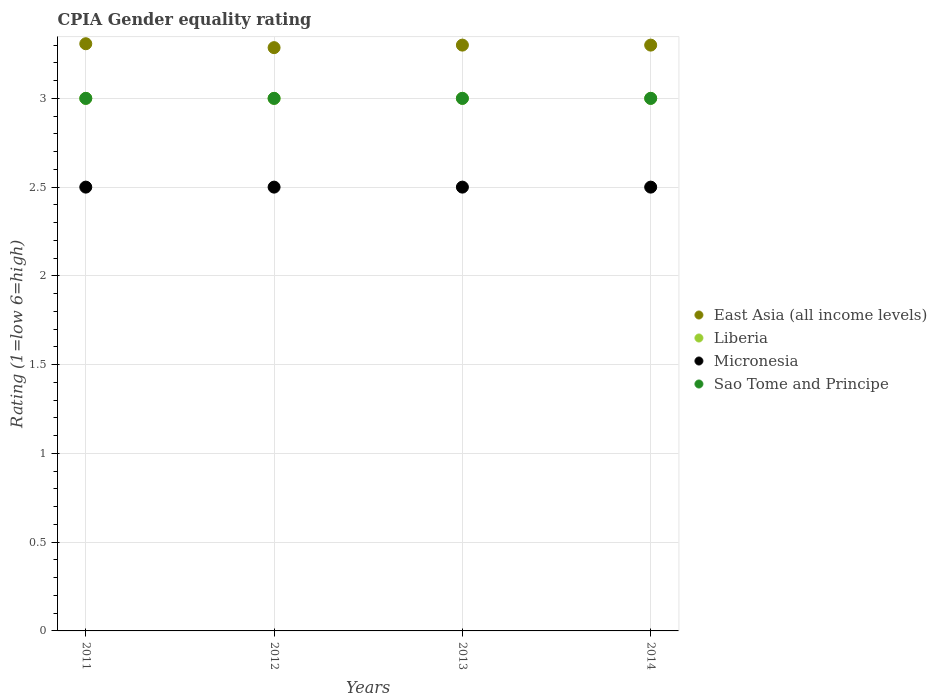How many different coloured dotlines are there?
Ensure brevity in your answer.  4. Is the number of dotlines equal to the number of legend labels?
Your response must be concise. Yes. Across all years, what is the maximum CPIA rating in Liberia?
Provide a succinct answer. 3. Across all years, what is the minimum CPIA rating in East Asia (all income levels)?
Make the answer very short. 3.29. In which year was the CPIA rating in East Asia (all income levels) maximum?
Provide a short and direct response. 2011. What is the total CPIA rating in Liberia in the graph?
Make the answer very short. 12. What is the difference between the CPIA rating in East Asia (all income levels) in 2013 and that in 2014?
Keep it short and to the point. 0. In the year 2011, what is the difference between the CPIA rating in Liberia and CPIA rating in Micronesia?
Your answer should be compact. 0.5. In how many years, is the CPIA rating in Micronesia greater than 1.2?
Offer a very short reply. 4. Is the difference between the CPIA rating in Liberia in 2013 and 2014 greater than the difference between the CPIA rating in Micronesia in 2013 and 2014?
Make the answer very short. No. What is the difference between the highest and the second highest CPIA rating in Micronesia?
Keep it short and to the point. 0. In how many years, is the CPIA rating in East Asia (all income levels) greater than the average CPIA rating in East Asia (all income levels) taken over all years?
Your response must be concise. 3. Does the CPIA rating in Sao Tome and Principe monotonically increase over the years?
Make the answer very short. No. Is the CPIA rating in Sao Tome and Principe strictly less than the CPIA rating in Liberia over the years?
Provide a succinct answer. No. What is the difference between two consecutive major ticks on the Y-axis?
Give a very brief answer. 0.5. Are the values on the major ticks of Y-axis written in scientific E-notation?
Your answer should be very brief. No. Does the graph contain any zero values?
Ensure brevity in your answer.  No. Where does the legend appear in the graph?
Your answer should be very brief. Center right. How many legend labels are there?
Your answer should be compact. 4. How are the legend labels stacked?
Provide a short and direct response. Vertical. What is the title of the graph?
Give a very brief answer. CPIA Gender equality rating. Does "Central African Republic" appear as one of the legend labels in the graph?
Your answer should be very brief. No. What is the label or title of the Y-axis?
Your answer should be very brief. Rating (1=low 6=high). What is the Rating (1=low 6=high) of East Asia (all income levels) in 2011?
Provide a short and direct response. 3.31. What is the Rating (1=low 6=high) in Liberia in 2011?
Make the answer very short. 3. What is the Rating (1=low 6=high) in Sao Tome and Principe in 2011?
Provide a succinct answer. 3. What is the Rating (1=low 6=high) in East Asia (all income levels) in 2012?
Your answer should be very brief. 3.29. What is the Rating (1=low 6=high) in Micronesia in 2012?
Ensure brevity in your answer.  2.5. What is the Rating (1=low 6=high) of Sao Tome and Principe in 2012?
Give a very brief answer. 3. What is the Rating (1=low 6=high) of Micronesia in 2013?
Your response must be concise. 2.5. Across all years, what is the maximum Rating (1=low 6=high) of East Asia (all income levels)?
Give a very brief answer. 3.31. Across all years, what is the maximum Rating (1=low 6=high) in Liberia?
Keep it short and to the point. 3. Across all years, what is the maximum Rating (1=low 6=high) of Micronesia?
Your answer should be very brief. 2.5. Across all years, what is the maximum Rating (1=low 6=high) in Sao Tome and Principe?
Keep it short and to the point. 3. Across all years, what is the minimum Rating (1=low 6=high) in East Asia (all income levels)?
Your answer should be very brief. 3.29. Across all years, what is the minimum Rating (1=low 6=high) in Micronesia?
Provide a short and direct response. 2.5. What is the total Rating (1=low 6=high) in East Asia (all income levels) in the graph?
Your answer should be very brief. 13.19. What is the total Rating (1=low 6=high) of Liberia in the graph?
Keep it short and to the point. 12. What is the total Rating (1=low 6=high) in Micronesia in the graph?
Offer a terse response. 10. What is the total Rating (1=low 6=high) of Sao Tome and Principe in the graph?
Offer a terse response. 12. What is the difference between the Rating (1=low 6=high) in East Asia (all income levels) in 2011 and that in 2012?
Keep it short and to the point. 0.02. What is the difference between the Rating (1=low 6=high) of Liberia in 2011 and that in 2012?
Provide a succinct answer. 0. What is the difference between the Rating (1=low 6=high) in Micronesia in 2011 and that in 2012?
Your answer should be very brief. 0. What is the difference between the Rating (1=low 6=high) of Sao Tome and Principe in 2011 and that in 2012?
Provide a succinct answer. 0. What is the difference between the Rating (1=low 6=high) in East Asia (all income levels) in 2011 and that in 2013?
Provide a short and direct response. 0.01. What is the difference between the Rating (1=low 6=high) of Liberia in 2011 and that in 2013?
Provide a succinct answer. 0. What is the difference between the Rating (1=low 6=high) of East Asia (all income levels) in 2011 and that in 2014?
Offer a very short reply. 0.01. What is the difference between the Rating (1=low 6=high) of Micronesia in 2011 and that in 2014?
Offer a terse response. 0. What is the difference between the Rating (1=low 6=high) in Sao Tome and Principe in 2011 and that in 2014?
Give a very brief answer. 0. What is the difference between the Rating (1=low 6=high) of East Asia (all income levels) in 2012 and that in 2013?
Provide a short and direct response. -0.01. What is the difference between the Rating (1=low 6=high) in Liberia in 2012 and that in 2013?
Offer a very short reply. 0. What is the difference between the Rating (1=low 6=high) in East Asia (all income levels) in 2012 and that in 2014?
Offer a terse response. -0.01. What is the difference between the Rating (1=low 6=high) in Sao Tome and Principe in 2012 and that in 2014?
Your answer should be compact. 0. What is the difference between the Rating (1=low 6=high) in East Asia (all income levels) in 2013 and that in 2014?
Your answer should be very brief. 0. What is the difference between the Rating (1=low 6=high) of East Asia (all income levels) in 2011 and the Rating (1=low 6=high) of Liberia in 2012?
Keep it short and to the point. 0.31. What is the difference between the Rating (1=low 6=high) of East Asia (all income levels) in 2011 and the Rating (1=low 6=high) of Micronesia in 2012?
Provide a short and direct response. 0.81. What is the difference between the Rating (1=low 6=high) of East Asia (all income levels) in 2011 and the Rating (1=low 6=high) of Sao Tome and Principe in 2012?
Offer a very short reply. 0.31. What is the difference between the Rating (1=low 6=high) in Liberia in 2011 and the Rating (1=low 6=high) in Micronesia in 2012?
Offer a terse response. 0.5. What is the difference between the Rating (1=low 6=high) of Micronesia in 2011 and the Rating (1=low 6=high) of Sao Tome and Principe in 2012?
Give a very brief answer. -0.5. What is the difference between the Rating (1=low 6=high) of East Asia (all income levels) in 2011 and the Rating (1=low 6=high) of Liberia in 2013?
Provide a succinct answer. 0.31. What is the difference between the Rating (1=low 6=high) of East Asia (all income levels) in 2011 and the Rating (1=low 6=high) of Micronesia in 2013?
Provide a succinct answer. 0.81. What is the difference between the Rating (1=low 6=high) in East Asia (all income levels) in 2011 and the Rating (1=low 6=high) in Sao Tome and Principe in 2013?
Your answer should be very brief. 0.31. What is the difference between the Rating (1=low 6=high) of Liberia in 2011 and the Rating (1=low 6=high) of Micronesia in 2013?
Provide a succinct answer. 0.5. What is the difference between the Rating (1=low 6=high) of Micronesia in 2011 and the Rating (1=low 6=high) of Sao Tome and Principe in 2013?
Ensure brevity in your answer.  -0.5. What is the difference between the Rating (1=low 6=high) in East Asia (all income levels) in 2011 and the Rating (1=low 6=high) in Liberia in 2014?
Keep it short and to the point. 0.31. What is the difference between the Rating (1=low 6=high) of East Asia (all income levels) in 2011 and the Rating (1=low 6=high) of Micronesia in 2014?
Provide a short and direct response. 0.81. What is the difference between the Rating (1=low 6=high) of East Asia (all income levels) in 2011 and the Rating (1=low 6=high) of Sao Tome and Principe in 2014?
Provide a succinct answer. 0.31. What is the difference between the Rating (1=low 6=high) in Liberia in 2011 and the Rating (1=low 6=high) in Sao Tome and Principe in 2014?
Provide a succinct answer. 0. What is the difference between the Rating (1=low 6=high) of East Asia (all income levels) in 2012 and the Rating (1=low 6=high) of Liberia in 2013?
Keep it short and to the point. 0.29. What is the difference between the Rating (1=low 6=high) in East Asia (all income levels) in 2012 and the Rating (1=low 6=high) in Micronesia in 2013?
Give a very brief answer. 0.79. What is the difference between the Rating (1=low 6=high) of East Asia (all income levels) in 2012 and the Rating (1=low 6=high) of Sao Tome and Principe in 2013?
Offer a terse response. 0.29. What is the difference between the Rating (1=low 6=high) of Liberia in 2012 and the Rating (1=low 6=high) of Sao Tome and Principe in 2013?
Keep it short and to the point. 0. What is the difference between the Rating (1=low 6=high) of East Asia (all income levels) in 2012 and the Rating (1=low 6=high) of Liberia in 2014?
Offer a very short reply. 0.29. What is the difference between the Rating (1=low 6=high) in East Asia (all income levels) in 2012 and the Rating (1=low 6=high) in Micronesia in 2014?
Your answer should be compact. 0.79. What is the difference between the Rating (1=low 6=high) of East Asia (all income levels) in 2012 and the Rating (1=low 6=high) of Sao Tome and Principe in 2014?
Ensure brevity in your answer.  0.29. What is the difference between the Rating (1=low 6=high) in Liberia in 2012 and the Rating (1=low 6=high) in Sao Tome and Principe in 2014?
Your response must be concise. 0. What is the difference between the Rating (1=low 6=high) in Micronesia in 2012 and the Rating (1=low 6=high) in Sao Tome and Principe in 2014?
Offer a terse response. -0.5. What is the difference between the Rating (1=low 6=high) in East Asia (all income levels) in 2013 and the Rating (1=low 6=high) in Micronesia in 2014?
Your response must be concise. 0.8. What is the difference between the Rating (1=low 6=high) in Micronesia in 2013 and the Rating (1=low 6=high) in Sao Tome and Principe in 2014?
Offer a terse response. -0.5. What is the average Rating (1=low 6=high) in East Asia (all income levels) per year?
Your answer should be very brief. 3.3. What is the average Rating (1=low 6=high) in Sao Tome and Principe per year?
Provide a short and direct response. 3. In the year 2011, what is the difference between the Rating (1=low 6=high) of East Asia (all income levels) and Rating (1=low 6=high) of Liberia?
Provide a short and direct response. 0.31. In the year 2011, what is the difference between the Rating (1=low 6=high) in East Asia (all income levels) and Rating (1=low 6=high) in Micronesia?
Your answer should be compact. 0.81. In the year 2011, what is the difference between the Rating (1=low 6=high) in East Asia (all income levels) and Rating (1=low 6=high) in Sao Tome and Principe?
Keep it short and to the point. 0.31. In the year 2011, what is the difference between the Rating (1=low 6=high) in Liberia and Rating (1=low 6=high) in Micronesia?
Provide a short and direct response. 0.5. In the year 2011, what is the difference between the Rating (1=low 6=high) of Liberia and Rating (1=low 6=high) of Sao Tome and Principe?
Offer a very short reply. 0. In the year 2012, what is the difference between the Rating (1=low 6=high) in East Asia (all income levels) and Rating (1=low 6=high) in Liberia?
Provide a succinct answer. 0.29. In the year 2012, what is the difference between the Rating (1=low 6=high) of East Asia (all income levels) and Rating (1=low 6=high) of Micronesia?
Your answer should be compact. 0.79. In the year 2012, what is the difference between the Rating (1=low 6=high) in East Asia (all income levels) and Rating (1=low 6=high) in Sao Tome and Principe?
Provide a short and direct response. 0.29. In the year 2012, what is the difference between the Rating (1=low 6=high) of Liberia and Rating (1=low 6=high) of Micronesia?
Provide a succinct answer. 0.5. In the year 2012, what is the difference between the Rating (1=low 6=high) of Liberia and Rating (1=low 6=high) of Sao Tome and Principe?
Your answer should be very brief. 0. In the year 2012, what is the difference between the Rating (1=low 6=high) of Micronesia and Rating (1=low 6=high) of Sao Tome and Principe?
Your answer should be compact. -0.5. In the year 2013, what is the difference between the Rating (1=low 6=high) of East Asia (all income levels) and Rating (1=low 6=high) of Sao Tome and Principe?
Your response must be concise. 0.3. In the year 2013, what is the difference between the Rating (1=low 6=high) in Micronesia and Rating (1=low 6=high) in Sao Tome and Principe?
Ensure brevity in your answer.  -0.5. In the year 2014, what is the difference between the Rating (1=low 6=high) of East Asia (all income levels) and Rating (1=low 6=high) of Liberia?
Offer a very short reply. 0.3. In the year 2014, what is the difference between the Rating (1=low 6=high) of East Asia (all income levels) and Rating (1=low 6=high) of Micronesia?
Keep it short and to the point. 0.8. In the year 2014, what is the difference between the Rating (1=low 6=high) in Liberia and Rating (1=low 6=high) in Micronesia?
Offer a terse response. 0.5. In the year 2014, what is the difference between the Rating (1=low 6=high) of Micronesia and Rating (1=low 6=high) of Sao Tome and Principe?
Your answer should be very brief. -0.5. What is the ratio of the Rating (1=low 6=high) in East Asia (all income levels) in 2011 to that in 2012?
Your answer should be compact. 1.01. What is the ratio of the Rating (1=low 6=high) of Liberia in 2011 to that in 2012?
Your response must be concise. 1. What is the ratio of the Rating (1=low 6=high) of Micronesia in 2011 to that in 2012?
Your answer should be compact. 1. What is the ratio of the Rating (1=low 6=high) in East Asia (all income levels) in 2011 to that in 2013?
Ensure brevity in your answer.  1. What is the ratio of the Rating (1=low 6=high) in Liberia in 2011 to that in 2013?
Give a very brief answer. 1. What is the ratio of the Rating (1=low 6=high) in East Asia (all income levels) in 2011 to that in 2014?
Your answer should be very brief. 1. What is the ratio of the Rating (1=low 6=high) of Liberia in 2011 to that in 2014?
Ensure brevity in your answer.  1. What is the ratio of the Rating (1=low 6=high) in Sao Tome and Principe in 2011 to that in 2014?
Provide a short and direct response. 1. What is the ratio of the Rating (1=low 6=high) of Micronesia in 2012 to that in 2013?
Your answer should be compact. 1. What is the ratio of the Rating (1=low 6=high) in Sao Tome and Principe in 2012 to that in 2013?
Provide a short and direct response. 1. What is the ratio of the Rating (1=low 6=high) in East Asia (all income levels) in 2012 to that in 2014?
Your answer should be very brief. 1. What is the ratio of the Rating (1=low 6=high) in Liberia in 2012 to that in 2014?
Offer a very short reply. 1. What is the ratio of the Rating (1=low 6=high) of Micronesia in 2012 to that in 2014?
Your response must be concise. 1. What is the ratio of the Rating (1=low 6=high) in Sao Tome and Principe in 2012 to that in 2014?
Offer a terse response. 1. What is the ratio of the Rating (1=low 6=high) of Liberia in 2013 to that in 2014?
Your response must be concise. 1. What is the ratio of the Rating (1=low 6=high) in Micronesia in 2013 to that in 2014?
Your response must be concise. 1. What is the difference between the highest and the second highest Rating (1=low 6=high) in East Asia (all income levels)?
Ensure brevity in your answer.  0.01. What is the difference between the highest and the second highest Rating (1=low 6=high) in Liberia?
Provide a short and direct response. 0. What is the difference between the highest and the second highest Rating (1=low 6=high) of Micronesia?
Your response must be concise. 0. What is the difference between the highest and the second highest Rating (1=low 6=high) in Sao Tome and Principe?
Your answer should be very brief. 0. What is the difference between the highest and the lowest Rating (1=low 6=high) in East Asia (all income levels)?
Provide a short and direct response. 0.02. What is the difference between the highest and the lowest Rating (1=low 6=high) in Liberia?
Your response must be concise. 0. 